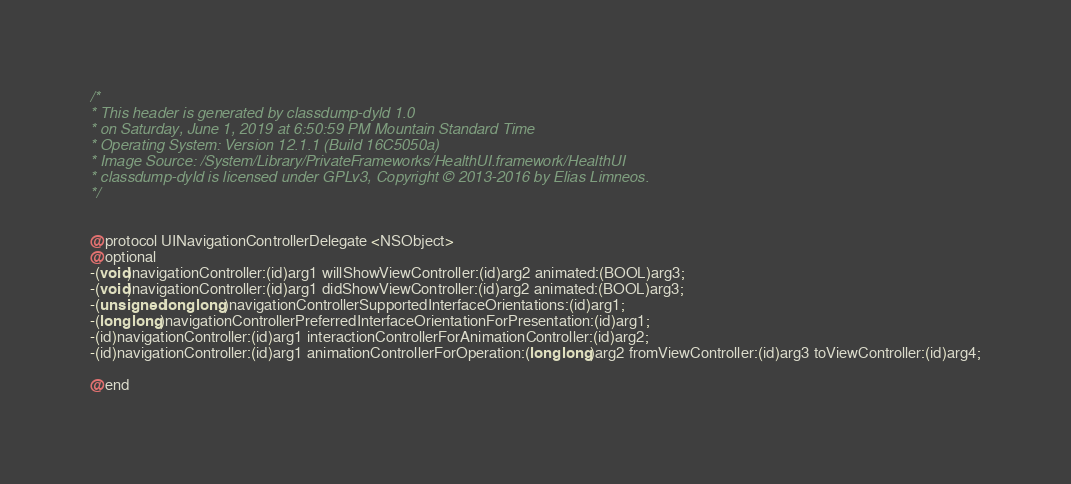Convert code to text. <code><loc_0><loc_0><loc_500><loc_500><_C_>/*
* This header is generated by classdump-dyld 1.0
* on Saturday, June 1, 2019 at 6:50:59 PM Mountain Standard Time
* Operating System: Version 12.1.1 (Build 16C5050a)
* Image Source: /System/Library/PrivateFrameworks/HealthUI.framework/HealthUI
* classdump-dyld is licensed under GPLv3, Copyright © 2013-2016 by Elias Limneos.
*/


@protocol UINavigationControllerDelegate <NSObject>
@optional
-(void)navigationController:(id)arg1 willShowViewController:(id)arg2 animated:(BOOL)arg3;
-(void)navigationController:(id)arg1 didShowViewController:(id)arg2 animated:(BOOL)arg3;
-(unsigned long long)navigationControllerSupportedInterfaceOrientations:(id)arg1;
-(long long)navigationControllerPreferredInterfaceOrientationForPresentation:(id)arg1;
-(id)navigationController:(id)arg1 interactionControllerForAnimationController:(id)arg2;
-(id)navigationController:(id)arg1 animationControllerForOperation:(long long)arg2 fromViewController:(id)arg3 toViewController:(id)arg4;

@end

</code> 